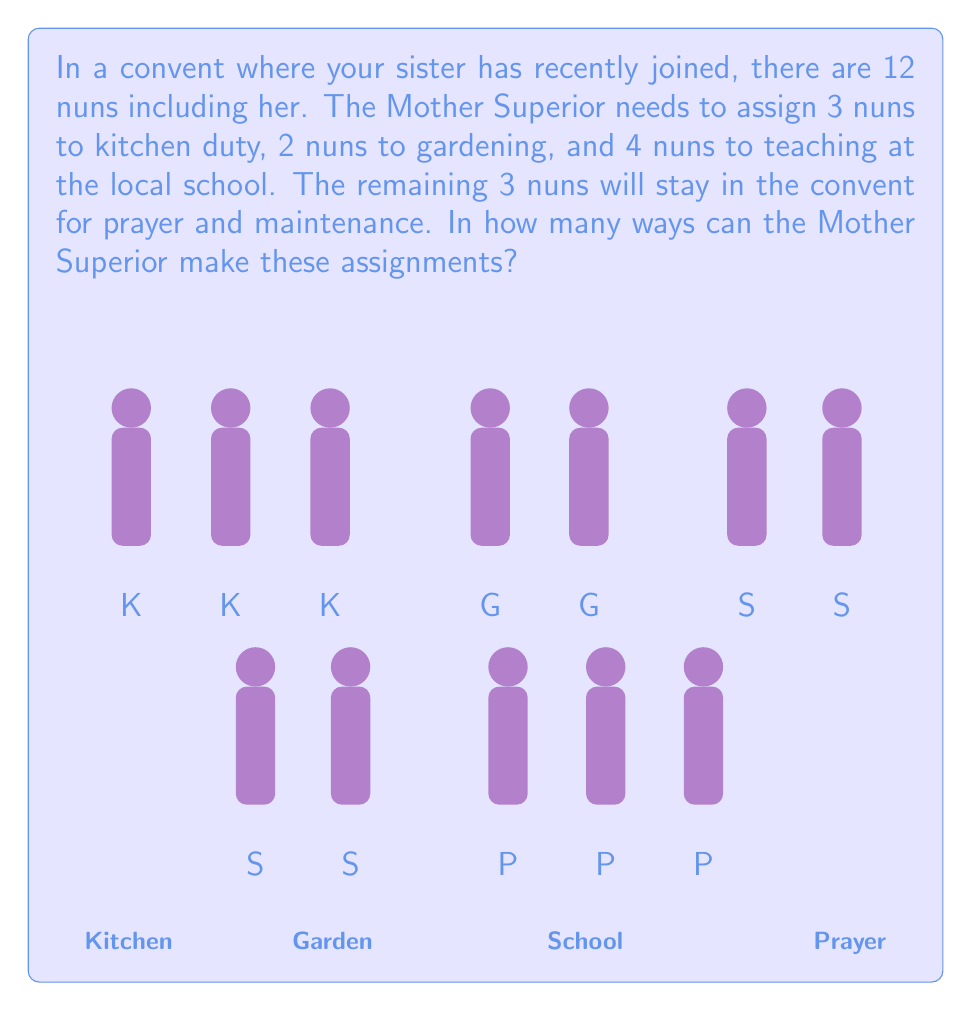Solve this math problem. Let's approach this step-by-step using the multiplication principle of combinatorics:

1) First, we need to choose 3 nuns for kitchen duty out of 12 nuns. This can be done in $\binom{12}{3}$ ways.

2) After selecting the kitchen duty nuns, we have 9 nuns left. From these, we need to choose 2 for gardening. This can be done in $\binom{9}{2}$ ways.

3) After kitchen and gardening assignments, we have 7 nuns left. From these, we need to choose 4 for teaching. This can be done in $\binom{7}{4}$ ways.

4) The remaining 3 nuns will automatically be assigned to prayer and maintenance.

5) By the multiplication principle, the total number of ways to make these assignments is:

   $$\binom{12}{3} \times \binom{9}{2} \times \binom{7}{4}$$

6) Let's calculate each combination:
   
   $\binom{12}{3} = \frac{12!}{3!(12-3)!} = \frac{12!}{3!9!} = 220$
   
   $\binom{9}{2} = \frac{9!}{2!(9-2)!} = \frac{9!}{2!7!} = 36$
   
   $\binom{7}{4} = \frac{7!}{4!(7-4)!} = \frac{7!}{4!3!} = 35$

7) Multiplying these together:

   $220 \times 36 \times 35 = 277,200$

Therefore, the Mother Superior can make these assignments in 277,200 different ways.
Answer: 277,200 